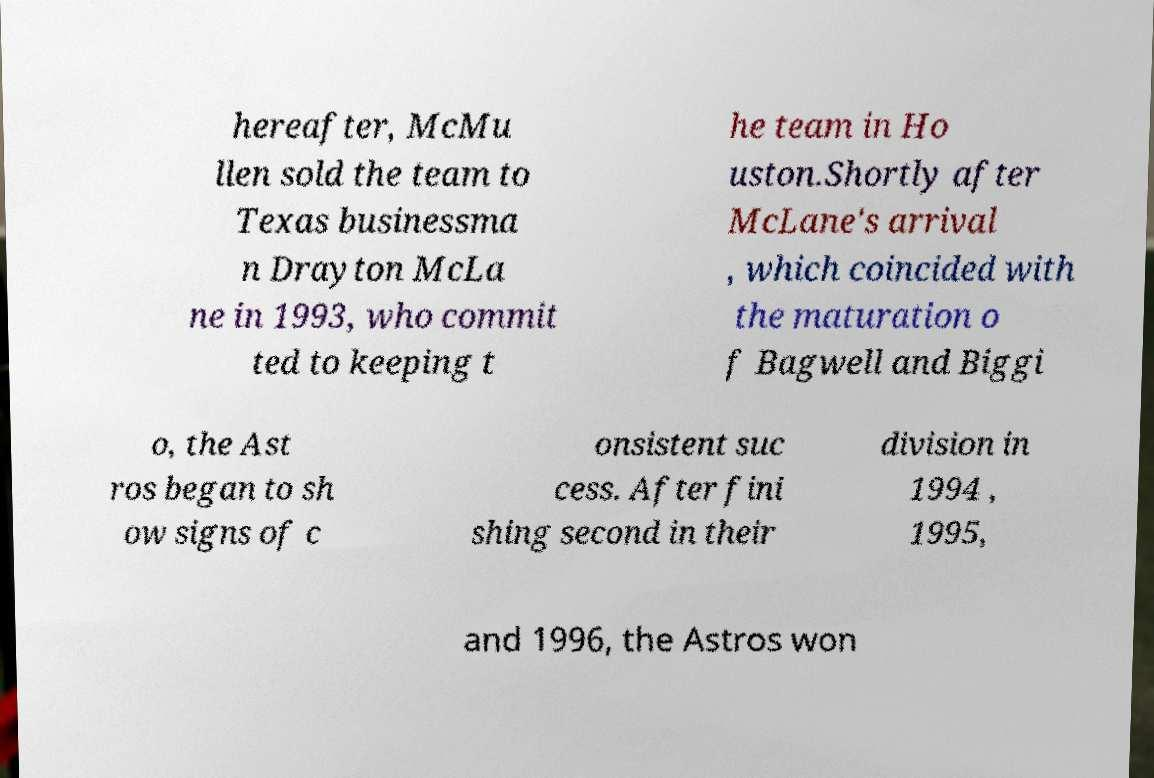For documentation purposes, I need the text within this image transcribed. Could you provide that? hereafter, McMu llen sold the team to Texas businessma n Drayton McLa ne in 1993, who commit ted to keeping t he team in Ho uston.Shortly after McLane's arrival , which coincided with the maturation o f Bagwell and Biggi o, the Ast ros began to sh ow signs of c onsistent suc cess. After fini shing second in their division in 1994 , 1995, and 1996, the Astros won 